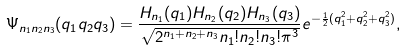Convert formula to latex. <formula><loc_0><loc_0><loc_500><loc_500>\Psi _ { n _ { 1 } n _ { 2 } n _ { 3 } } ( q _ { 1 } q _ { 2 } q _ { 3 } ) = \frac { H _ { n _ { 1 } } ( q _ { 1 } ) H _ { n _ { 2 } } ( q _ { 2 } ) H _ { n _ { 3 } } ( q _ { 3 } ) } { \sqrt { 2 ^ { n _ { 1 } + n _ { 2 } + n _ { 3 } } n _ { 1 } ! n _ { 2 } ! n _ { 3 } ! \pi ^ { 3 } } } e ^ { - \frac { 1 } { 2 } ( q _ { 1 } ^ { 2 } + q _ { 2 } ^ { 2 } + q _ { 3 } ^ { 2 } ) } ,</formula> 